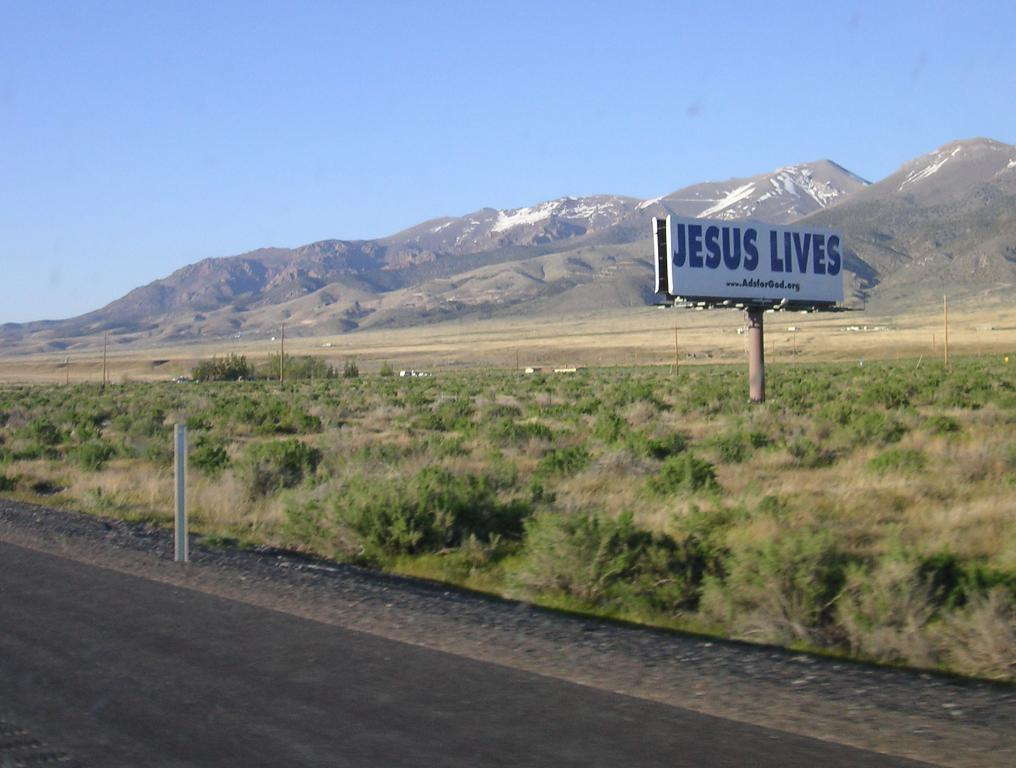<image>
Give a short and clear explanation of the subsequent image. A billboard that simply states JESUS LIVES out in the desert. 